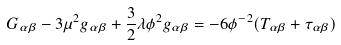Convert formula to latex. <formula><loc_0><loc_0><loc_500><loc_500>G _ { \alpha \beta } - 3 \mu ^ { 2 } g _ { \alpha \beta } + \frac { 3 } { 2 } \lambda \phi ^ { 2 } g _ { \alpha \beta } = - 6 \phi ^ { - 2 } ( T _ { \alpha \beta } + \tau _ { \alpha \beta } )</formula> 